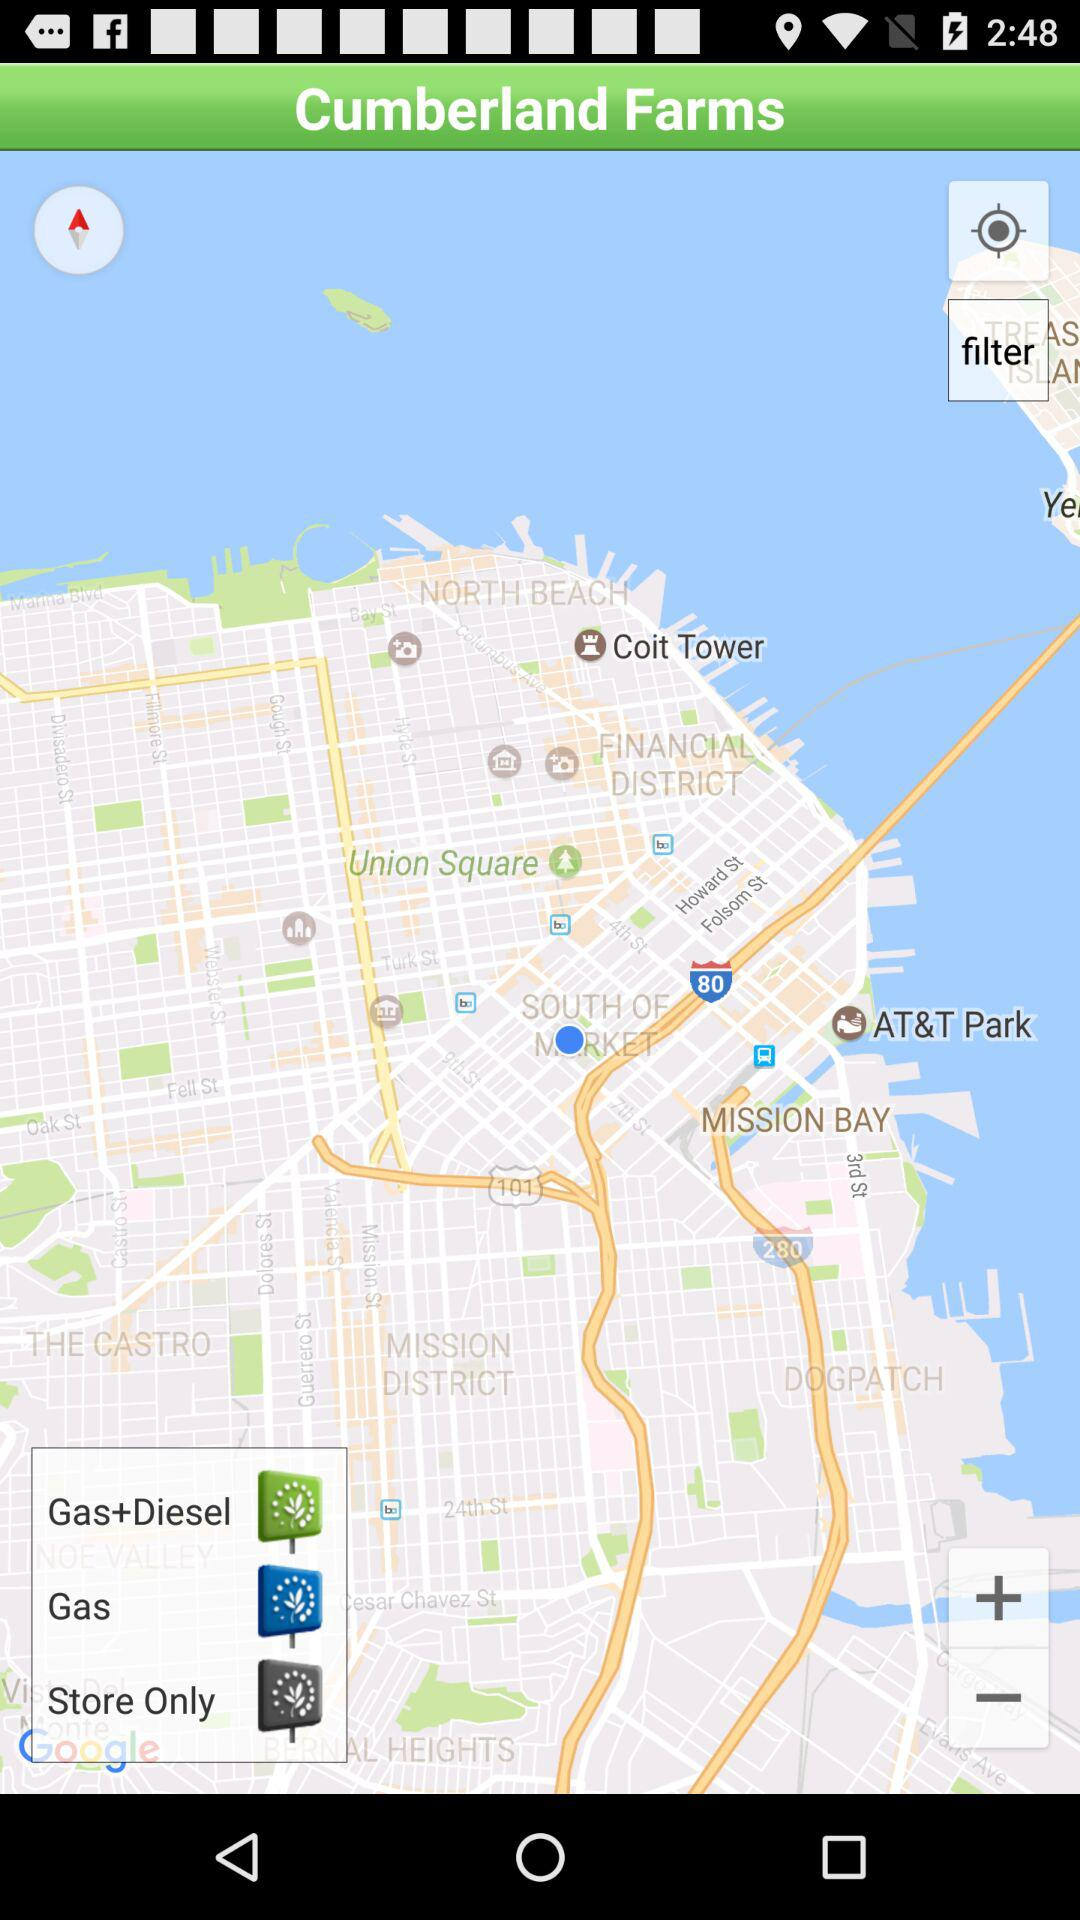What is the application name? The application name is "Cumberland Farms". 